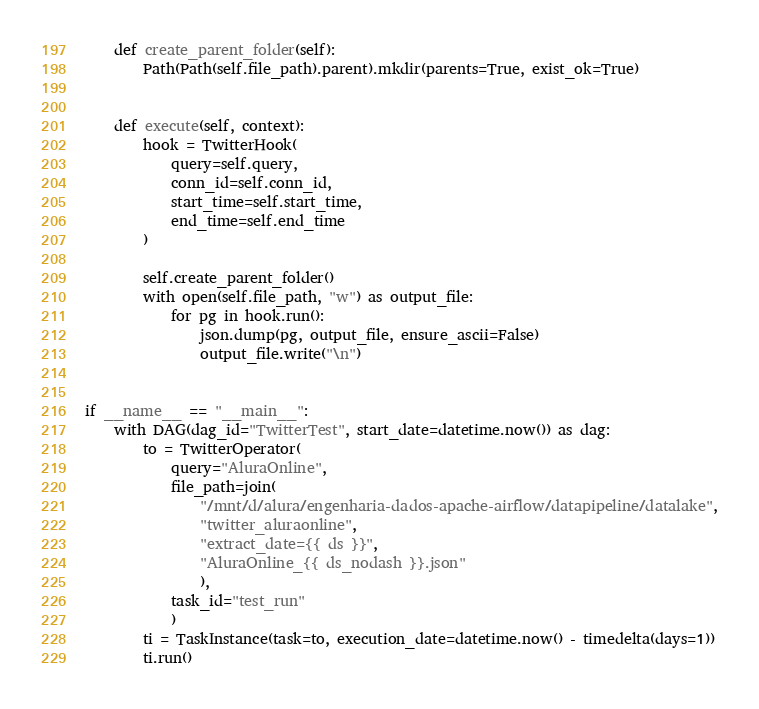<code> <loc_0><loc_0><loc_500><loc_500><_Python_>
    def create_parent_folder(self):
        Path(Path(self.file_path).parent).mkdir(parents=True, exist_ok=True)


    def execute(self, context):
        hook = TwitterHook(
            query=self.query,
            conn_id=self.conn_id,
            start_time=self.start_time,
            end_time=self.end_time
        )
        
        self.create_parent_folder()
        with open(self.file_path, "w") as output_file:
            for pg in hook.run():
                json.dump(pg, output_file, ensure_ascii=False)
                output_file.write("\n")


if __name__ == "__main__":
    with DAG(dag_id="TwitterTest", start_date=datetime.now()) as dag:
        to = TwitterOperator(
            query="AluraOnline",
            file_path=join(
                "/mnt/d/alura/engenharia-dados-apache-airflow/datapipeline/datalake",
                "twitter_aluraonline",
                "extract_date={{ ds }}",
                "AluraOnline_{{ ds_nodash }}.json"
                ),
            task_id="test_run"
            )
        ti = TaskInstance(task=to, execution_date=datetime.now() - timedelta(days=1))
        ti.run()
</code> 